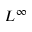Convert formula to latex. <formula><loc_0><loc_0><loc_500><loc_500>L ^ { \infty }</formula> 